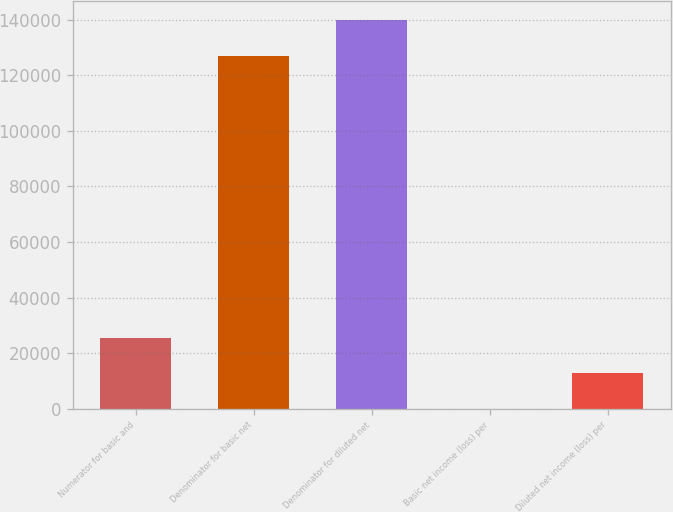Convert chart to OTSL. <chart><loc_0><loc_0><loc_500><loc_500><bar_chart><fcel>Numerator for basic and<fcel>Denominator for basic net<fcel>Denominator for diluted net<fcel>Basic net income (loss) per<fcel>Diluted net income (loss) per<nl><fcel>25424.3<fcel>127121<fcel>139833<fcel>0.13<fcel>12712.2<nl></chart> 